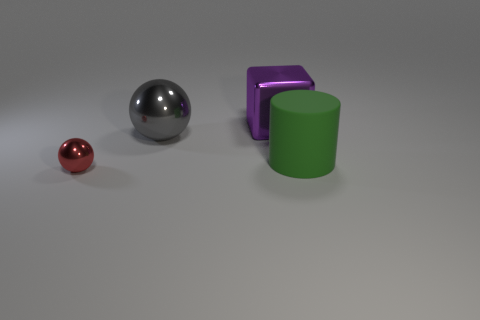Add 1 large matte cylinders. How many objects exist? 5 Subtract all blocks. How many objects are left? 3 Subtract 0 yellow cubes. How many objects are left? 4 Subtract all tiny gray metal things. Subtract all large metal blocks. How many objects are left? 3 Add 2 rubber objects. How many rubber objects are left? 3 Add 3 tiny blue metal cylinders. How many tiny blue metal cylinders exist? 3 